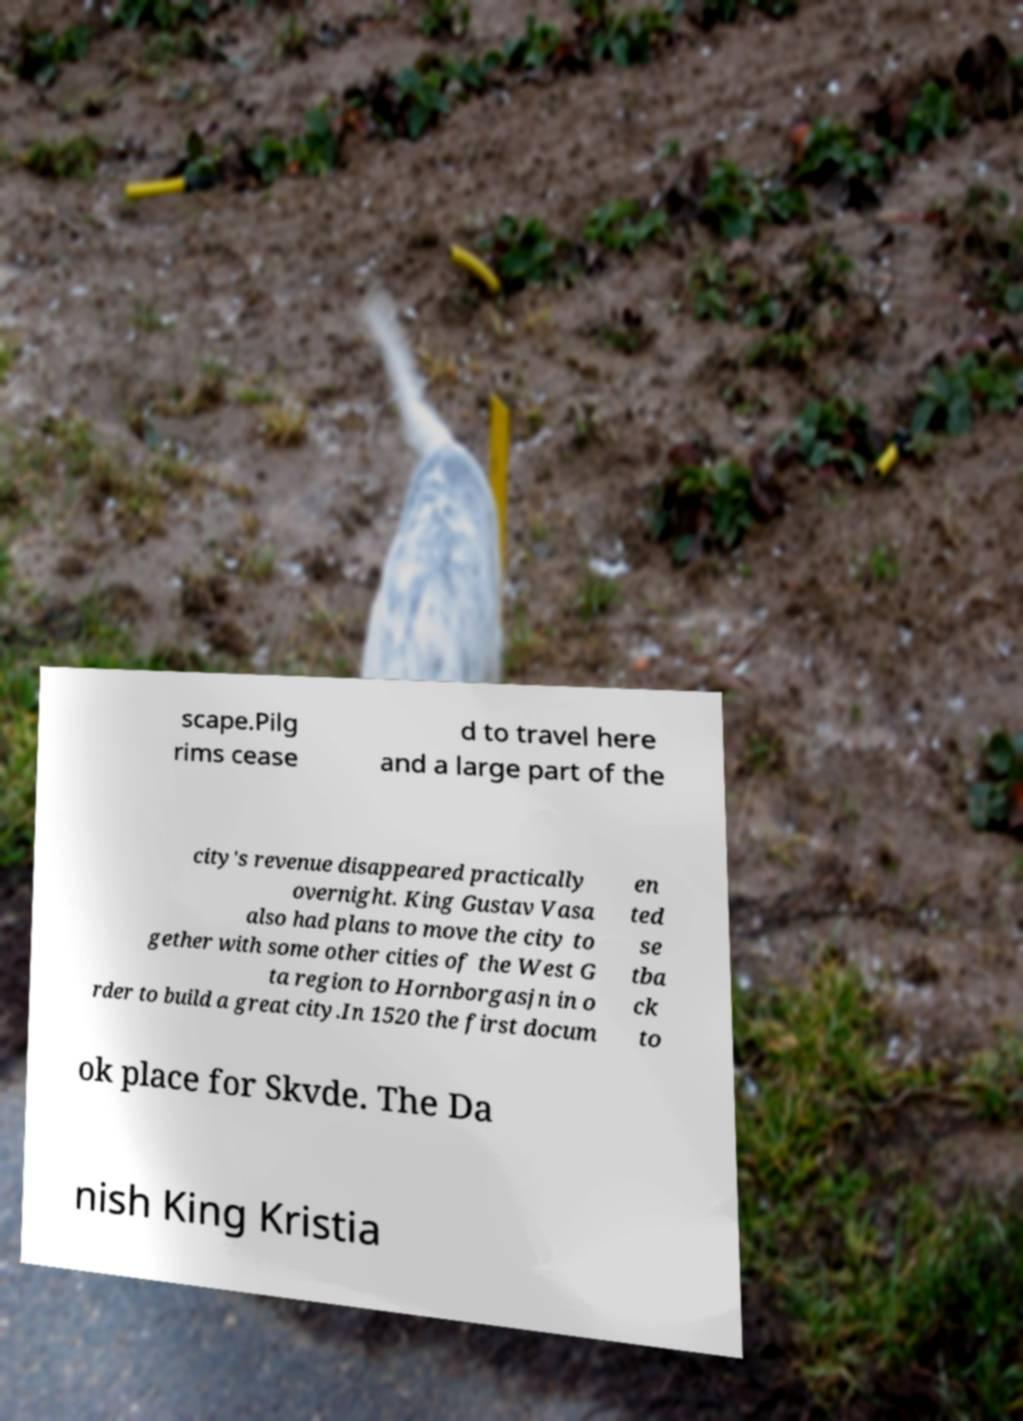Please read and relay the text visible in this image. What does it say? scape.Pilg rims cease d to travel here and a large part of the city's revenue disappeared practically overnight. King Gustav Vasa also had plans to move the city to gether with some other cities of the West G ta region to Hornborgasjn in o rder to build a great city.In 1520 the first docum en ted se tba ck to ok place for Skvde. The Da nish King Kristia 